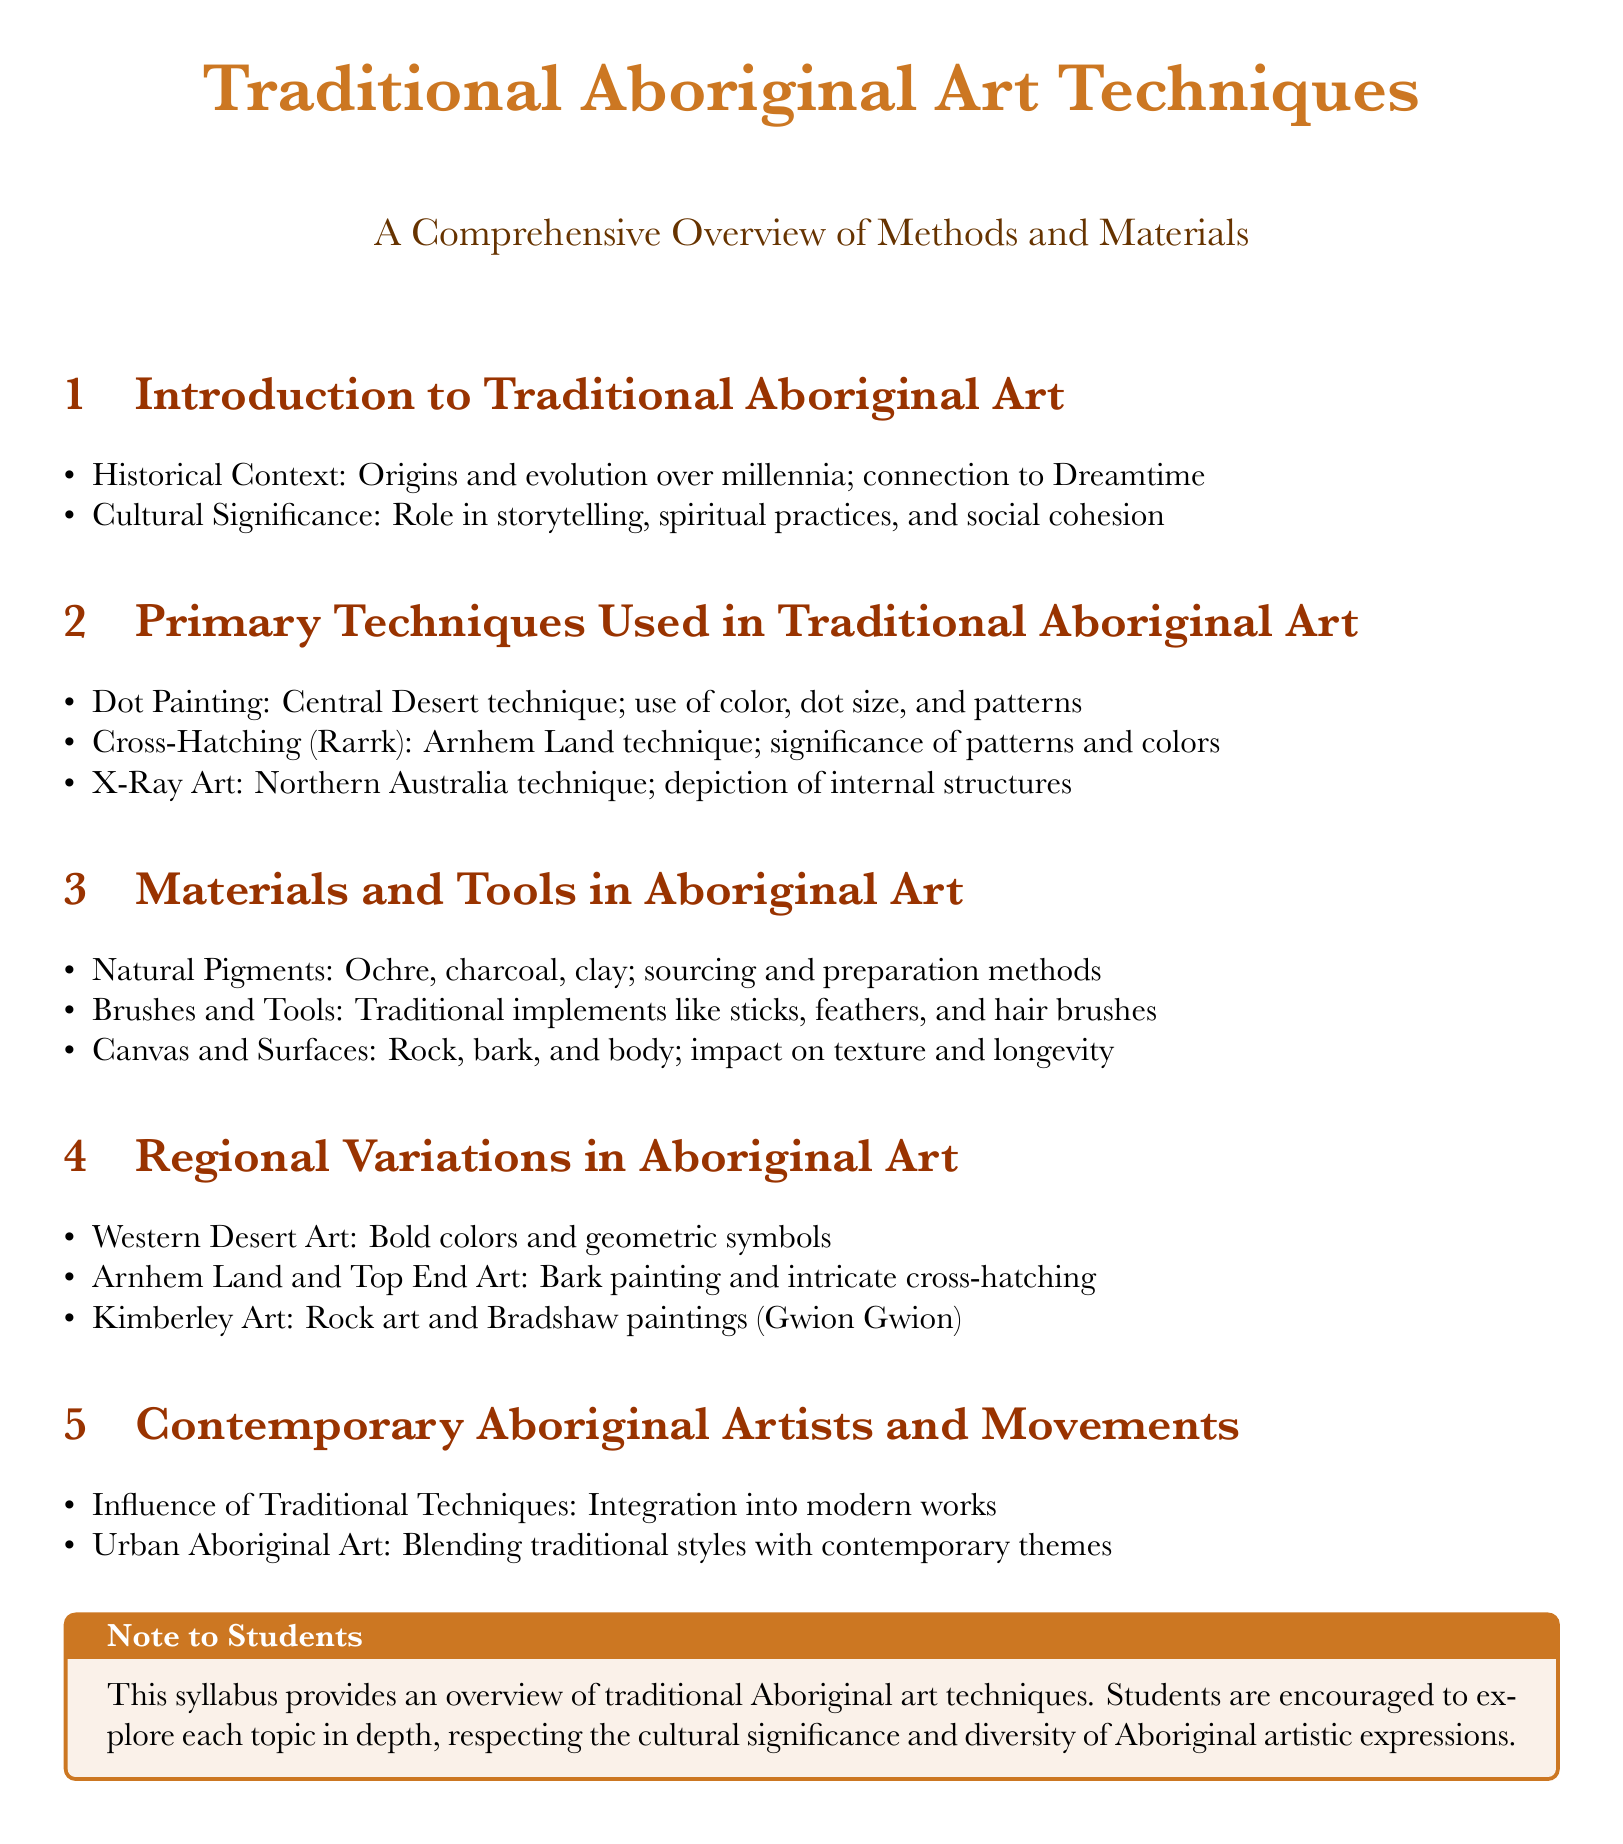What are the three primary techniques used in traditional Aboriginal art? The document lists Dot Painting, Cross-Hatching (Rarrk), and X-Ray Art as the primary techniques.
Answer: Dot Painting, Cross-Hatching (Rarrk), X-Ray Art What is the cultural significance of traditional Aboriginal art? The document states that traditional Aboriginal art plays a role in storytelling, spiritual practices, and social cohesion.
Answer: Storytelling, spiritual practices, social cohesion Which region is associated with bold colors and geometric symbols in Aboriginal art? The document identifies Western Desert Art as the region characterized by bold colors and geometric symbols.
Answer: Western Desert Art What are the natural pigments mentioned in the syllabus? The document specifies ochre, charcoal, and clay as the natural pigments used in Aboriginal art.
Answer: Ochre, charcoal, clay What does the box at the end of the document emphasize for students? The note to students encourages exploration of each topic in depth while respecting cultural significance.
Answer: Exploration of each topic in depth, respecting cultural significance 